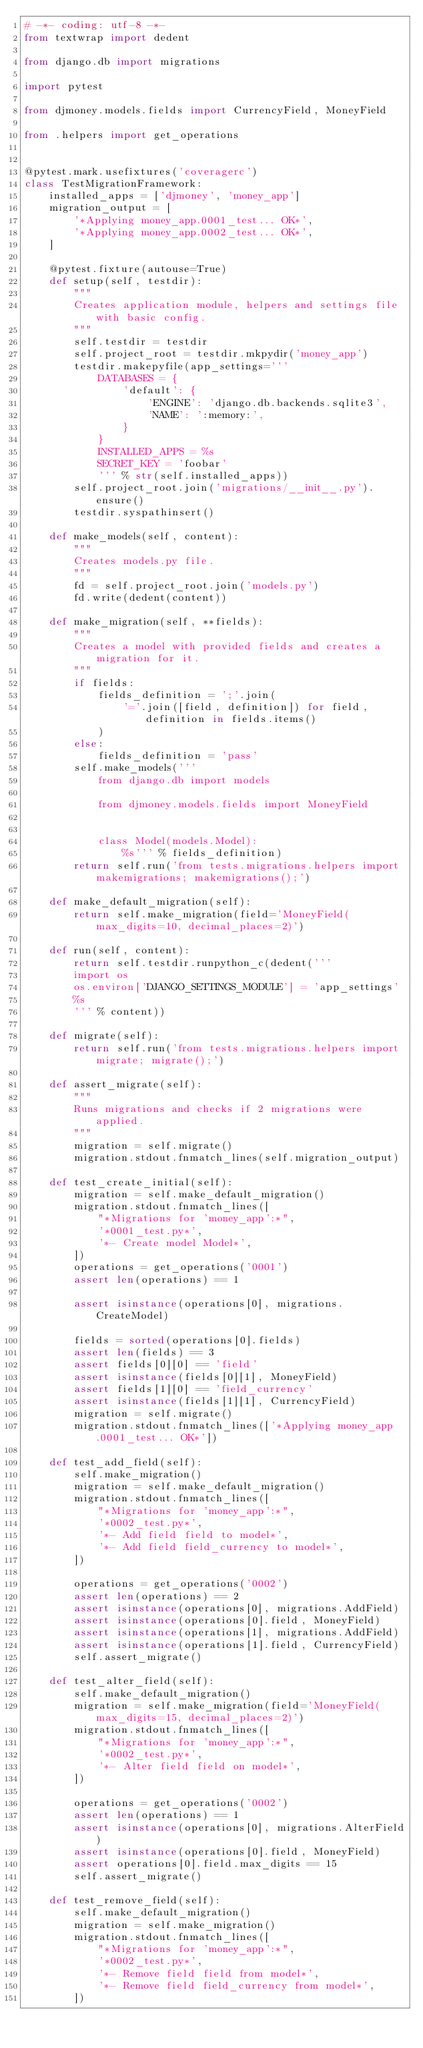<code> <loc_0><loc_0><loc_500><loc_500><_Python_># -*- coding: utf-8 -*-
from textwrap import dedent

from django.db import migrations

import pytest

from djmoney.models.fields import CurrencyField, MoneyField

from .helpers import get_operations


@pytest.mark.usefixtures('coveragerc')
class TestMigrationFramework:
    installed_apps = ['djmoney', 'money_app']
    migration_output = [
        '*Applying money_app.0001_test... OK*',
        '*Applying money_app.0002_test... OK*',
    ]

    @pytest.fixture(autouse=True)
    def setup(self, testdir):
        """
        Creates application module, helpers and settings file with basic config.
        """
        self.testdir = testdir
        self.project_root = testdir.mkpydir('money_app')
        testdir.makepyfile(app_settings='''
            DATABASES = {
                'default': {
                    'ENGINE': 'django.db.backends.sqlite3',
                    'NAME': ':memory:',
                }
            }
            INSTALLED_APPS = %s
            SECRET_KEY = 'foobar'
            ''' % str(self.installed_apps))
        self.project_root.join('migrations/__init__.py').ensure()
        testdir.syspathinsert()

    def make_models(self, content):
        """
        Creates models.py file.
        """
        fd = self.project_root.join('models.py')
        fd.write(dedent(content))

    def make_migration(self, **fields):
        """
        Creates a model with provided fields and creates a migration for it.
        """
        if fields:
            fields_definition = ';'.join(
                '='.join([field, definition]) for field, definition in fields.items()
            )
        else:
            fields_definition = 'pass'
        self.make_models('''
            from django.db import models

            from djmoney.models.fields import MoneyField


            class Model(models.Model):
                %s''' % fields_definition)
        return self.run('from tests.migrations.helpers import makemigrations; makemigrations();')

    def make_default_migration(self):
        return self.make_migration(field='MoneyField(max_digits=10, decimal_places=2)')

    def run(self, content):
        return self.testdir.runpython_c(dedent('''
        import os
        os.environ['DJANGO_SETTINGS_MODULE'] = 'app_settings'
        %s
        ''' % content))

    def migrate(self):
        return self.run('from tests.migrations.helpers import migrate; migrate();')

    def assert_migrate(self):
        """
        Runs migrations and checks if 2 migrations were applied.
        """
        migration = self.migrate()
        migration.stdout.fnmatch_lines(self.migration_output)

    def test_create_initial(self):
        migration = self.make_default_migration()
        migration.stdout.fnmatch_lines([
            "*Migrations for 'money_app':*",
            '*0001_test.py*',
            '*- Create model Model*',
        ])
        operations = get_operations('0001')
        assert len(operations) == 1

        assert isinstance(operations[0], migrations.CreateModel)

        fields = sorted(operations[0].fields)
        assert len(fields) == 3
        assert fields[0][0] == 'field'
        assert isinstance(fields[0][1], MoneyField)
        assert fields[1][0] == 'field_currency'
        assert isinstance(fields[1][1], CurrencyField)
        migration = self.migrate()
        migration.stdout.fnmatch_lines(['*Applying money_app.0001_test... OK*'])

    def test_add_field(self):
        self.make_migration()
        migration = self.make_default_migration()
        migration.stdout.fnmatch_lines([
            "*Migrations for 'money_app':*",
            '*0002_test.py*',
            '*- Add field field to model*',
            '*- Add field field_currency to model*',
        ])

        operations = get_operations('0002')
        assert len(operations) == 2
        assert isinstance(operations[0], migrations.AddField)
        assert isinstance(operations[0].field, MoneyField)
        assert isinstance(operations[1], migrations.AddField)
        assert isinstance(operations[1].field, CurrencyField)
        self.assert_migrate()

    def test_alter_field(self):
        self.make_default_migration()
        migration = self.make_migration(field='MoneyField(max_digits=15, decimal_places=2)')
        migration.stdout.fnmatch_lines([
            "*Migrations for 'money_app':*",
            '*0002_test.py*',
            '*- Alter field field on model*',
        ])

        operations = get_operations('0002')
        assert len(operations) == 1
        assert isinstance(operations[0], migrations.AlterField)
        assert isinstance(operations[0].field, MoneyField)
        assert operations[0].field.max_digits == 15
        self.assert_migrate()

    def test_remove_field(self):
        self.make_default_migration()
        migration = self.make_migration()
        migration.stdout.fnmatch_lines([
            "*Migrations for 'money_app':*",
            '*0002_test.py*',
            '*- Remove field field from model*',
            '*- Remove field field_currency from model*',
        ])
</code> 